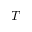Convert formula to latex. <formula><loc_0><loc_0><loc_500><loc_500>T</formula> 